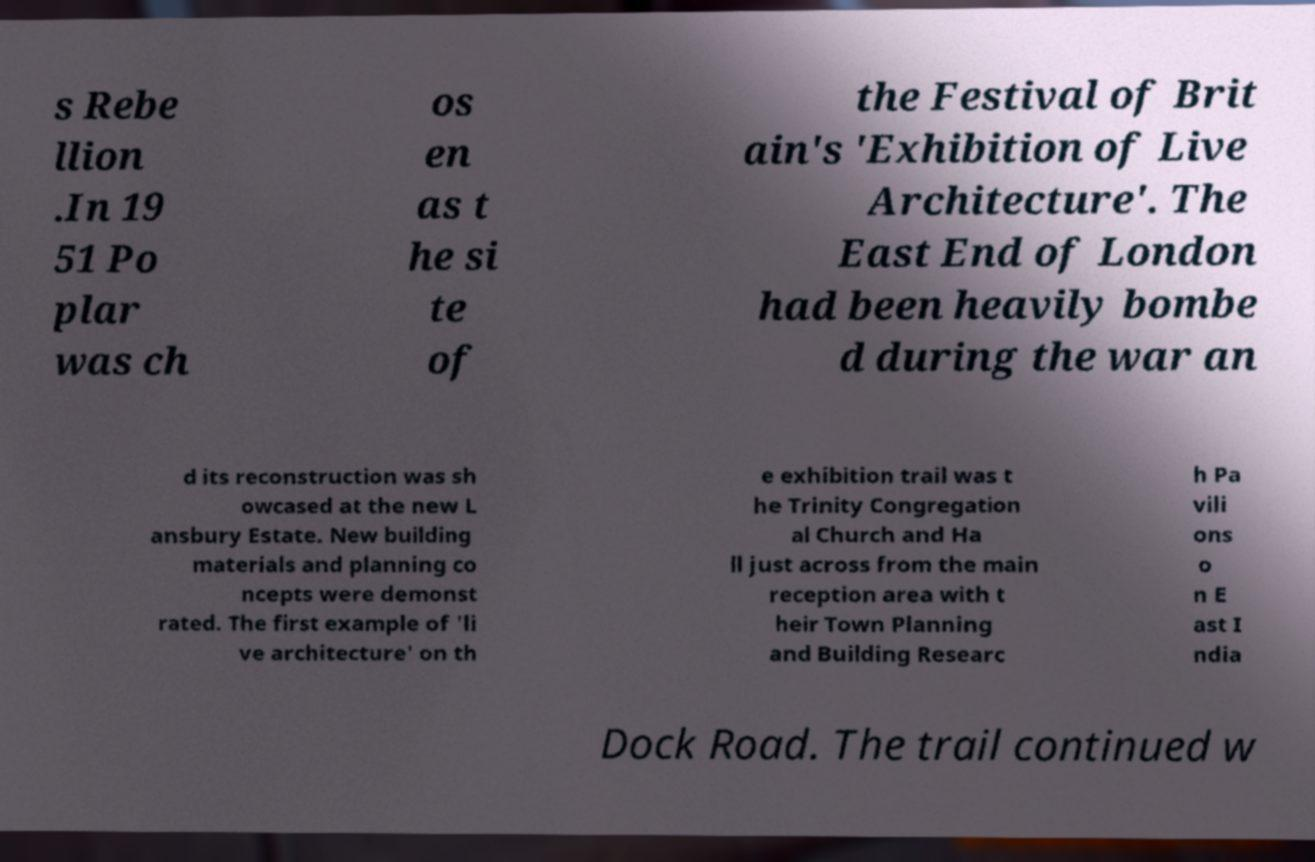Can you accurately transcribe the text from the provided image for me? s Rebe llion .In 19 51 Po plar was ch os en as t he si te of the Festival of Brit ain's 'Exhibition of Live Architecture'. The East End of London had been heavily bombe d during the war an d its reconstruction was sh owcased at the new L ansbury Estate. New building materials and planning co ncepts were demonst rated. The first example of 'li ve architecture' on th e exhibition trail was t he Trinity Congregation al Church and Ha ll just across from the main reception area with t heir Town Planning and Building Researc h Pa vili ons o n E ast I ndia Dock Road. The trail continued w 